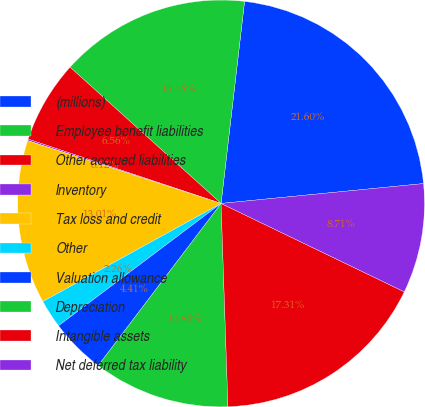Convert chart to OTSL. <chart><loc_0><loc_0><loc_500><loc_500><pie_chart><fcel>(millions)<fcel>Employee benefit liabilities<fcel>Other accrued liabilities<fcel>Inventory<fcel>Tax loss and credit<fcel>Other<fcel>Valuation allowance<fcel>Depreciation<fcel>Intangible assets<fcel>Net deferred tax liability<nl><fcel>21.6%<fcel>15.16%<fcel>6.56%<fcel>0.12%<fcel>13.01%<fcel>2.26%<fcel>4.41%<fcel>10.86%<fcel>17.31%<fcel>8.71%<nl></chart> 